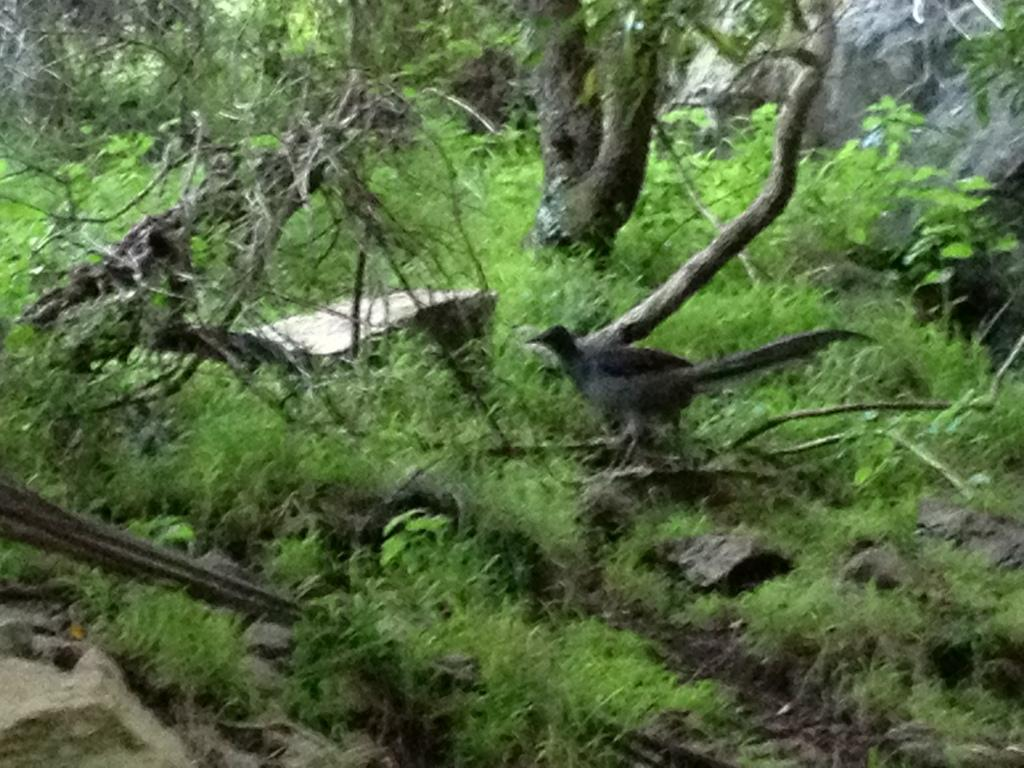What type of animal can be seen in the image? There is a bird in the image. Where is the bird located in the image? The bird is standing in the grass. What type of vegetation is present on the ground in the image? There is grass, stones, and sticks present on the ground in the image. What can be seen in the background of the image? There are trees in the background of the image. What letters are being used by the bird to communicate in the image? There are no letters present in the image, and the bird is not communicating with any written language. 